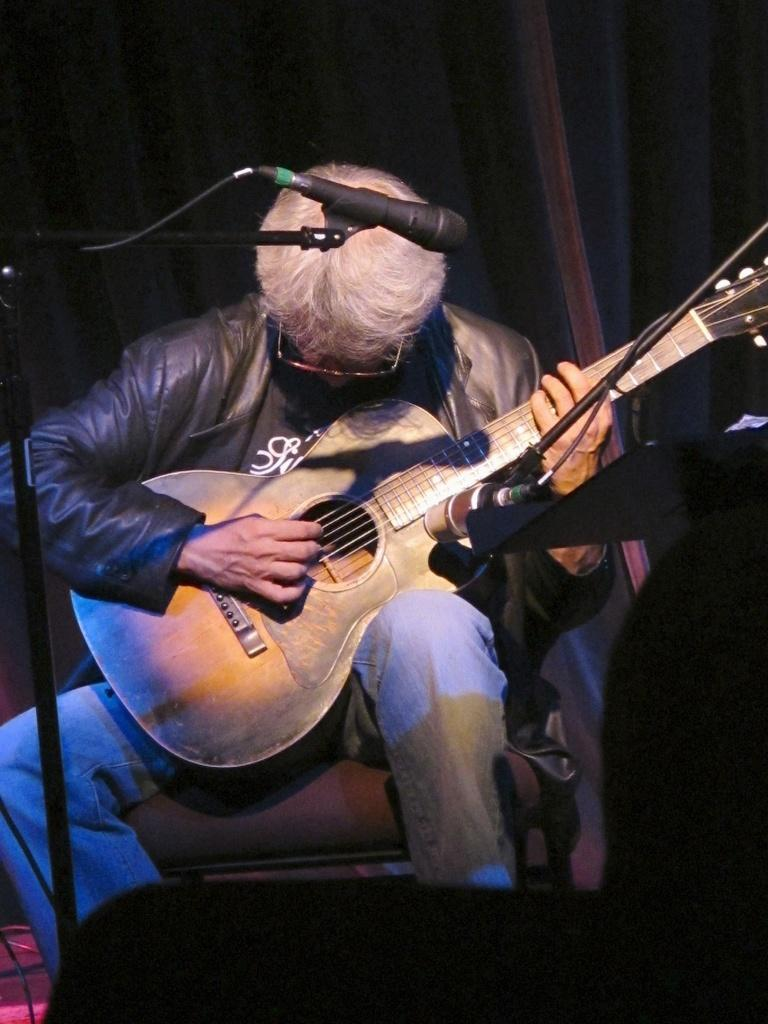Who or what is the main subject in the image? There is a person in the image. What is the person doing in the image? The person is sitting on a chair. What object is the person holding in the image? The person is holding a guitar in his hand. What type of cup is visible on the stage in the image? There is no cup or stage present in the image; it features a person sitting on a chair and holding a guitar. 